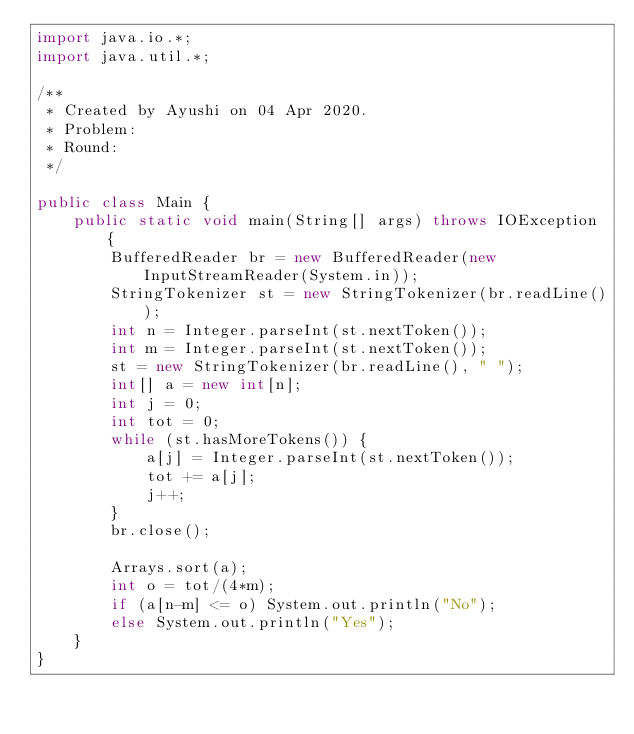<code> <loc_0><loc_0><loc_500><loc_500><_Java_>import java.io.*;
import java.util.*;

/**
 * Created by Ayushi on 04 Apr 2020.
 * Problem:
 * Round:
 */

public class Main {
    public static void main(String[] args) throws IOException {
        BufferedReader br = new BufferedReader(new InputStreamReader(System.in));
        StringTokenizer st = new StringTokenizer(br.readLine());
        int n = Integer.parseInt(st.nextToken());
        int m = Integer.parseInt(st.nextToken());
        st = new StringTokenizer(br.readLine(), " ");
        int[] a = new int[n];
        int j = 0;
        int tot = 0;
        while (st.hasMoreTokens()) {
            a[j] = Integer.parseInt(st.nextToken());
            tot += a[j];
            j++;
        }
        br.close();

        Arrays.sort(a);
        int o = tot/(4*m);
        if (a[n-m] <= o) System.out.println("No");
        else System.out.println("Yes");
    }
}
</code> 